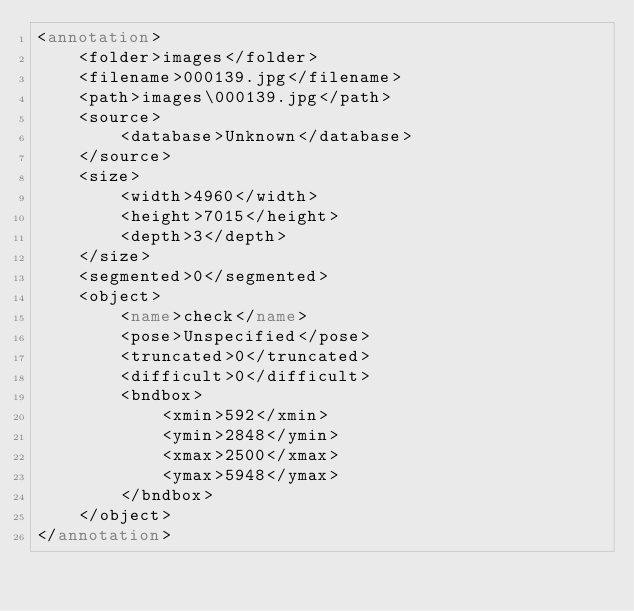<code> <loc_0><loc_0><loc_500><loc_500><_XML_><annotation>
	<folder>images</folder>
	<filename>000139.jpg</filename>
	<path>images\000139.jpg</path>
	<source>
		<database>Unknown</database>
	</source>
	<size>
		<width>4960</width>
		<height>7015</height>
		<depth>3</depth>
	</size>
	<segmented>0</segmented>
	<object>
		<name>check</name>
		<pose>Unspecified</pose>
		<truncated>0</truncated>
		<difficult>0</difficult>
		<bndbox>
			<xmin>592</xmin>
			<ymin>2848</ymin>
			<xmax>2500</xmax>
			<ymax>5948</ymax>
		</bndbox>
	</object>
</annotation></code> 